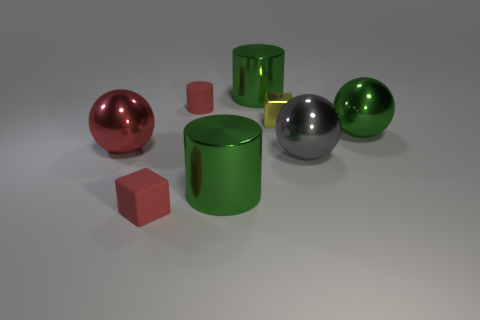Add 2 green rubber cubes. How many objects exist? 10 Subtract all cylinders. How many objects are left? 5 Subtract all small gray objects. Subtract all yellow metallic blocks. How many objects are left? 7 Add 7 large gray metallic balls. How many large gray metallic balls are left? 8 Add 5 blue rubber balls. How many blue rubber balls exist? 5 Subtract 0 purple blocks. How many objects are left? 8 